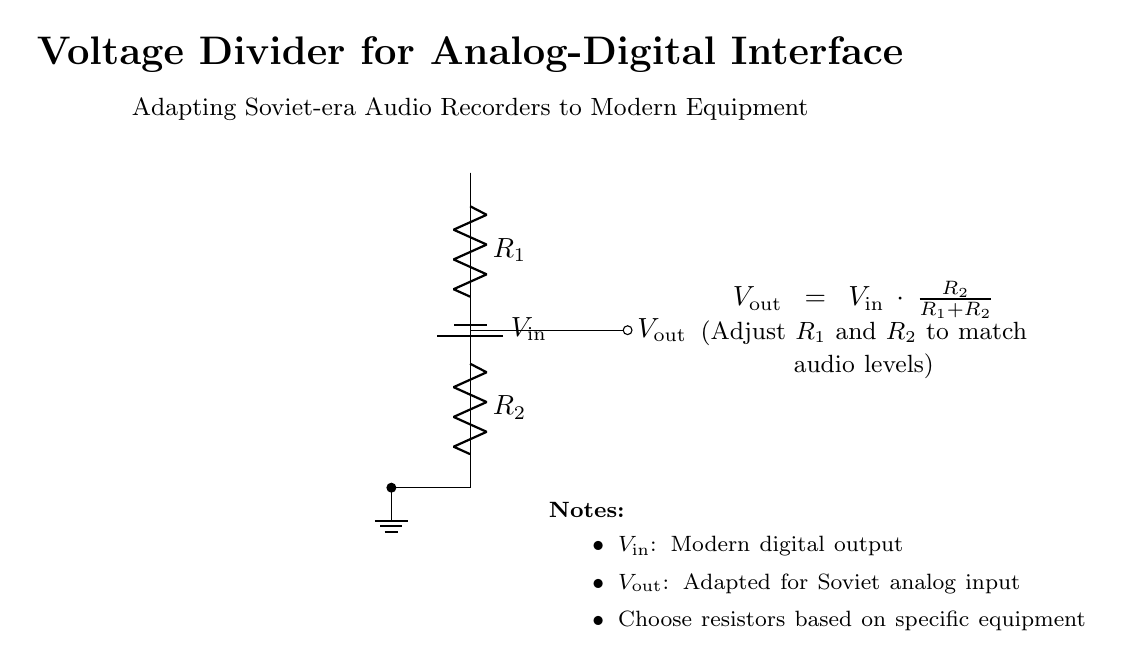What components are present in the circuit? The circuit includes a battery, two resistors, and output leads. The battery provides the input voltage, and the resistors form the voltage divider.
Answer: battery, resistors, output leads What is the function of R1 and R2 in this circuit? R1 and R2 are resistors that divide the input voltage. Their values determine how much of the input voltage appears at the output.
Answer: voltage division What is the output voltage formula? The output voltage is calculated using the formula \( V_{out} = V_{in} \cdot \frac{R_2}{R_1 + R_2} \), which describes the relationship between the resistors and the input voltage.
Answer: Vout = Vin * (R2 / (R1 + R2)) If R1 is 1k ohm and R2 is 2k ohm, what is the output voltage when the input voltage is 6V? Substituting into the formula gives \( V_{out} = 6V \cdot \frac{2000}{1000 + 2000} = 6V \cdot \frac{2000}{3000} = 4V \).
Answer: 4V Why might someone adjust the values of R1 and R2? Adjusting R1 and R2 allows the user to match the output voltage to the required input voltage levels of the older analog equipment to prevent damage or ensure proper signal levels.
Answer: to match audio levels What is the purpose of the ground connection in this circuit? The ground connection is essential for providing a reference point for the circuit voltages, ensuring that the voltage levels can be accurately measured and are relative to a common return path.
Answer: reference point What type of circuit is depicted in this diagram? The circuit is a voltage divider, specifically designed for interfacing modern digital signals with older analog devices to control the voltage levels accordingly.
Answer: voltage divider 